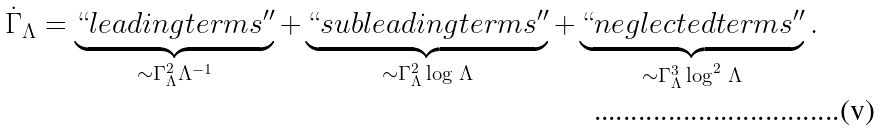<formula> <loc_0><loc_0><loc_500><loc_500>\dot { \Gamma } _ { \Lambda } = \underbrace { ` ` l e a d i n g t e r m s ^ { \prime \prime } } _ { \sim \Gamma _ { \Lambda } ^ { 2 } \Lambda ^ { - 1 } } + \underbrace { ` ` s u b l e a d i n g t e r m s ^ { \prime \prime } } _ { \sim \Gamma _ { \Lambda } ^ { 2 } \log \, \Lambda } + \underbrace { ` ` n e g l e c t e d t e r m s ^ { \prime \prime } } _ { \sim \Gamma ^ { 3 } _ { \Lambda } \log ^ { 2 } \, \Lambda } .</formula> 